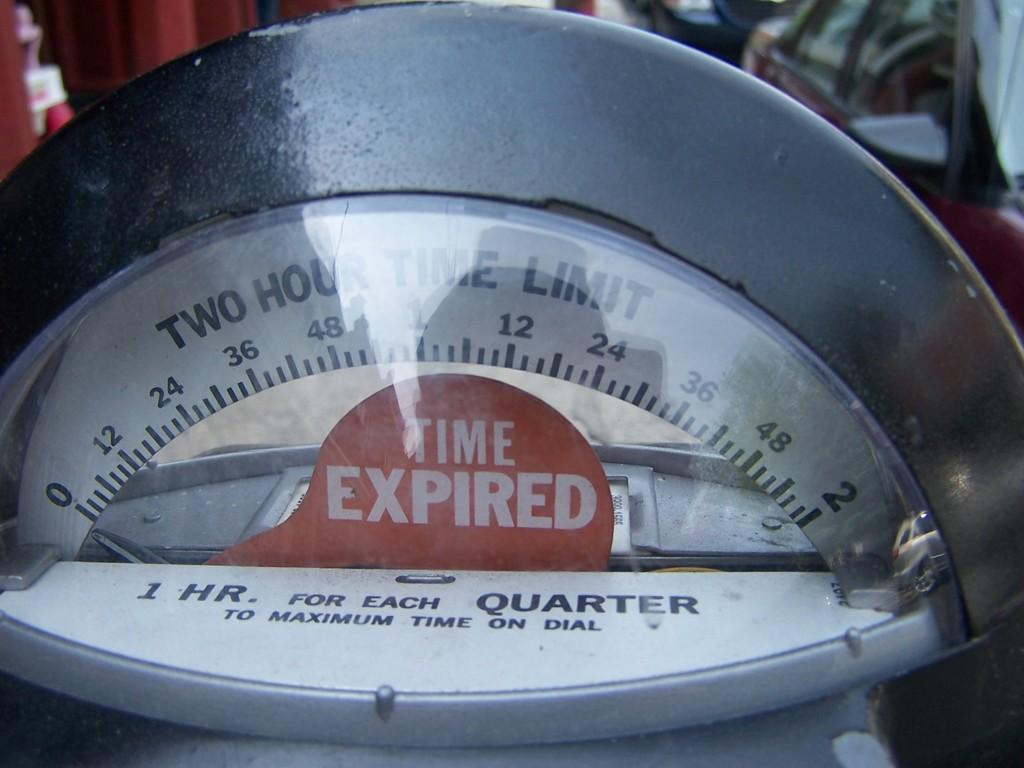<image>
Offer a succinct explanation of the picture presented. The parking meter warns that time has now expired. 